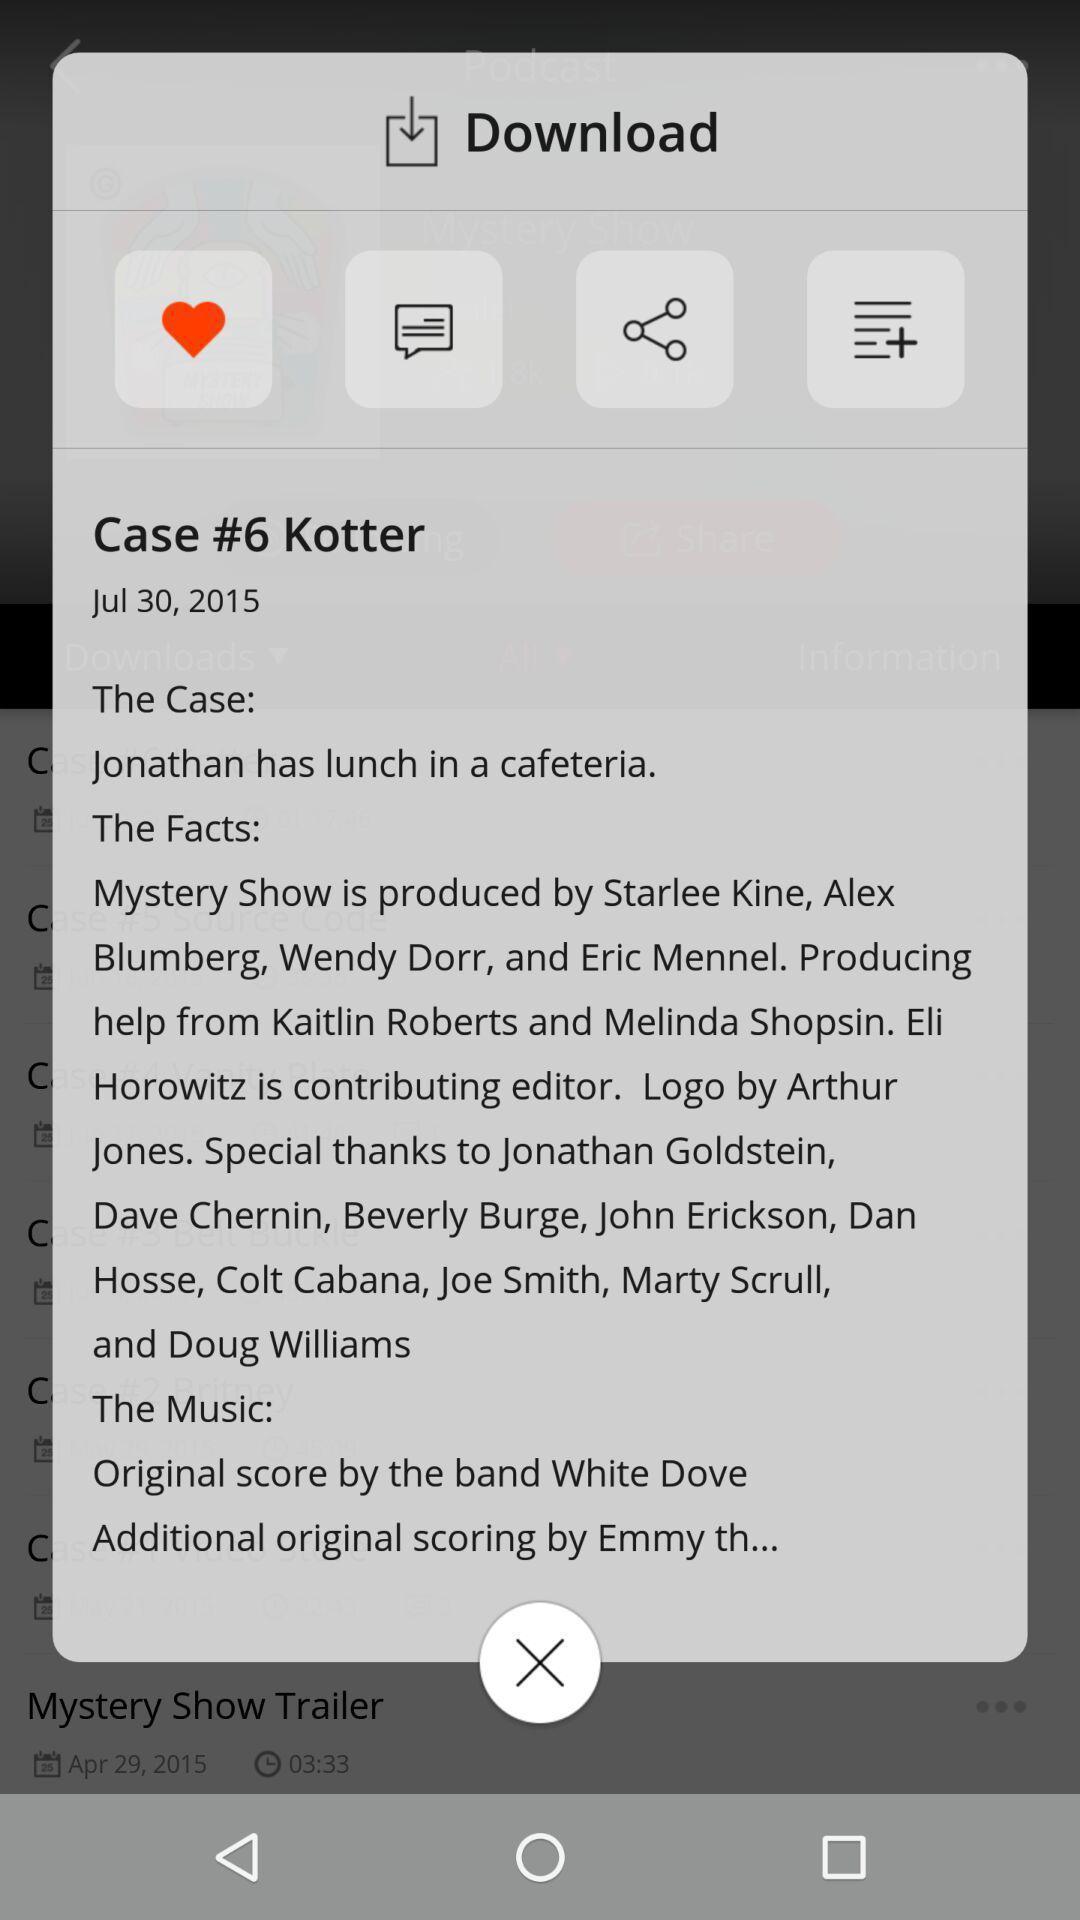What is the overall content of this screenshot? Pop-up showing movie information with multiple icons. 